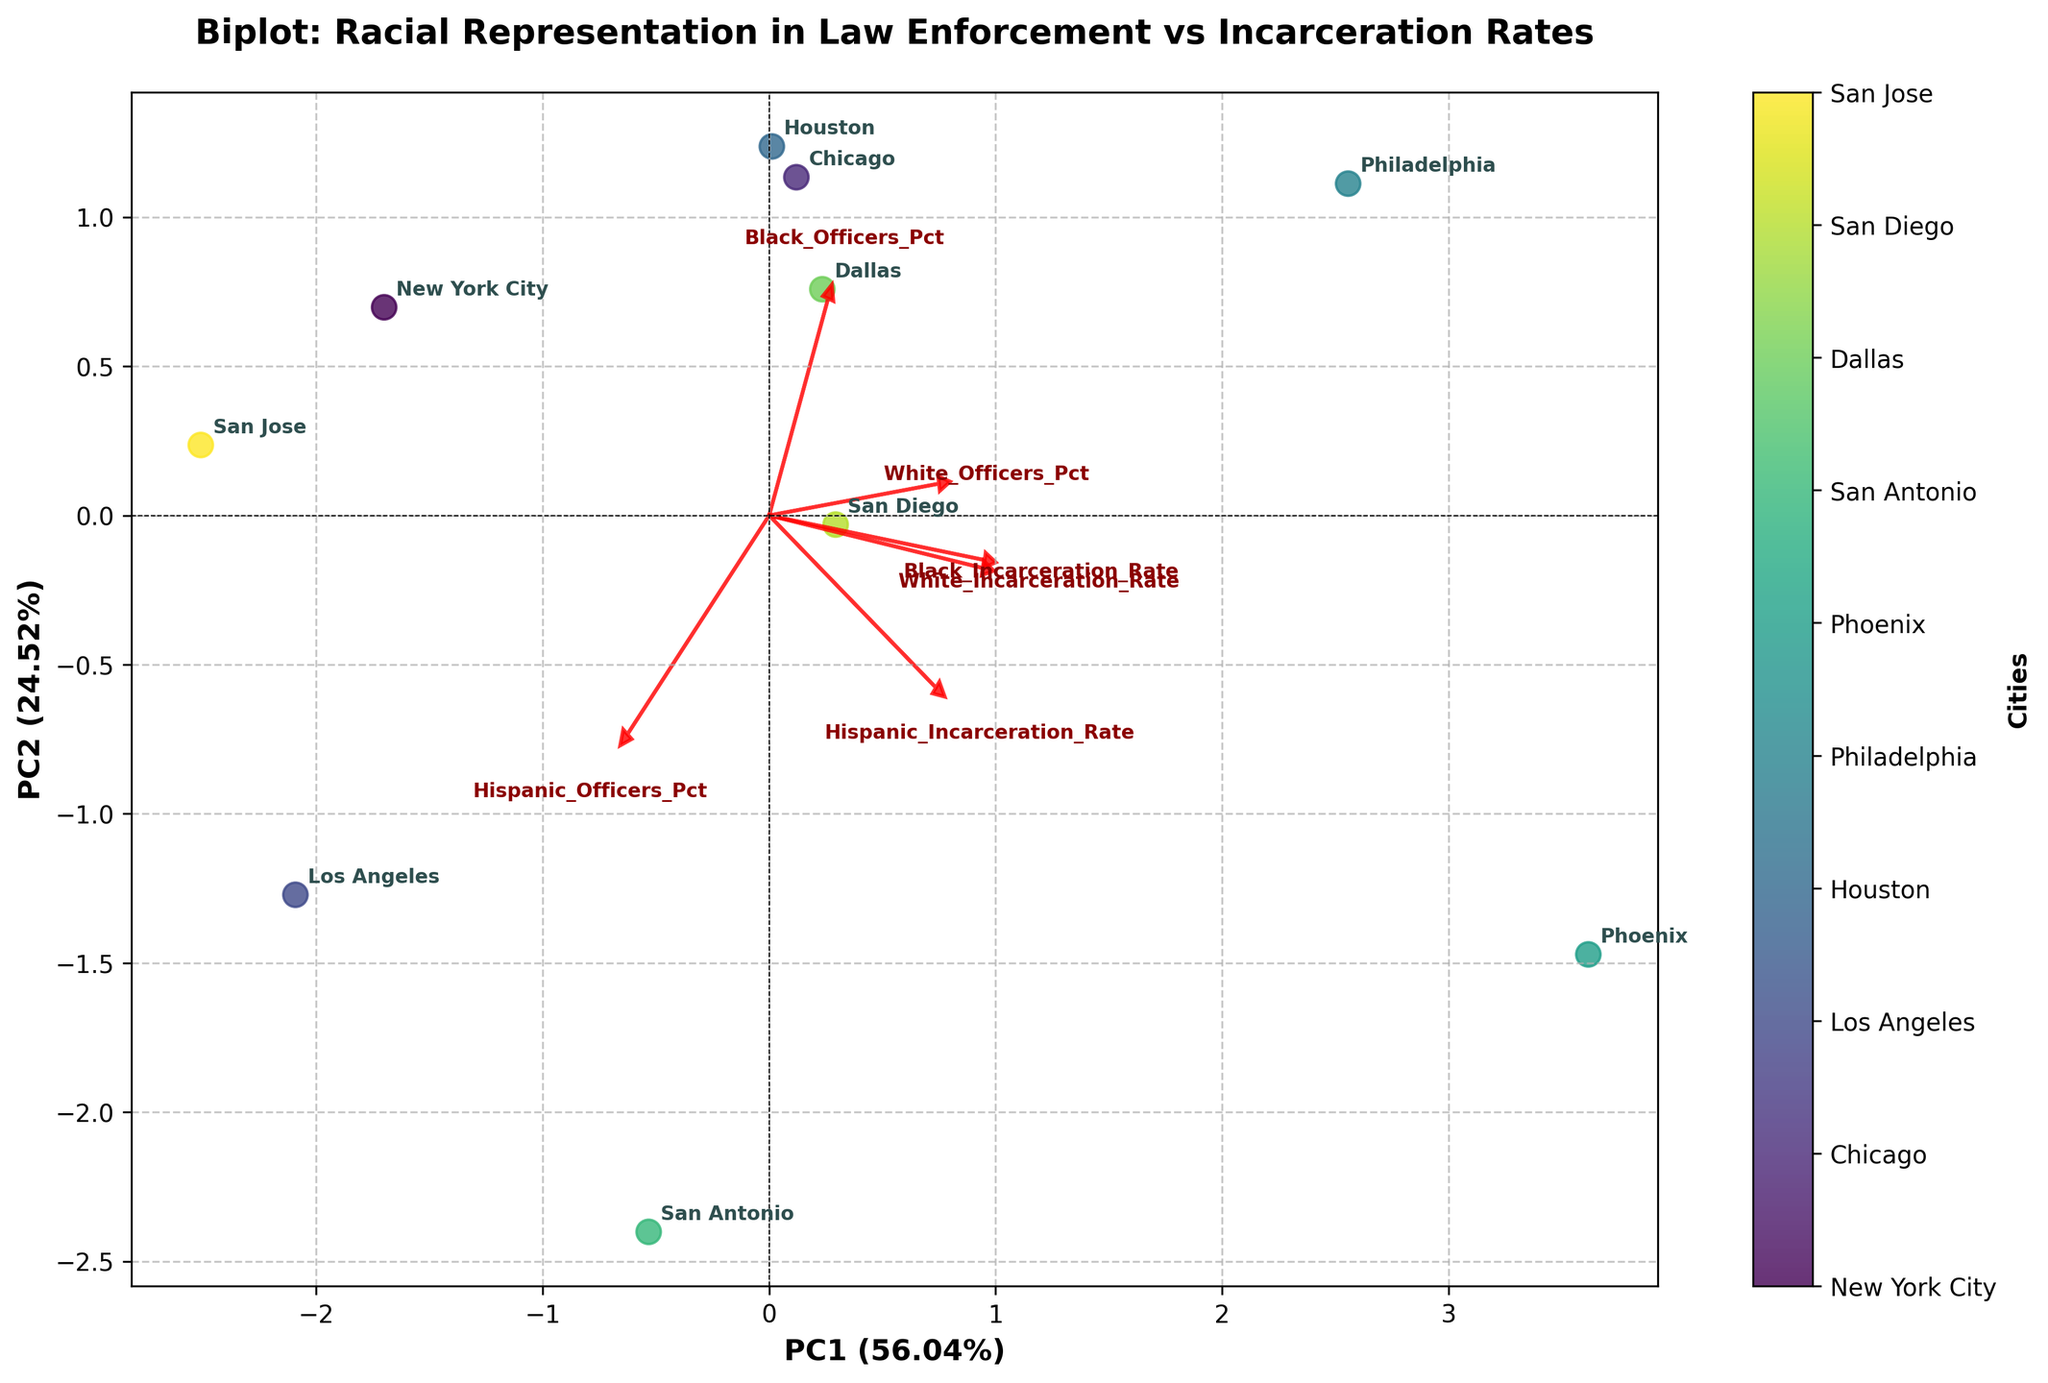What is the title of the biplot? The title is displayed at the top of the figure. It reads "Biplot: Racial Representation in Law Enforcement vs Incarceration Rates".
Answer: Biplot: Racial Representation in Law Enforcement vs Incarceration Rates How many cities are represented in the biplot? Count the number of unique labels (one for each city) annotated in the plot. There are labels for "New York City", "Chicago", "Los Angeles", "Houston", "Philadelphia", "Phoenix", "San Antonio", "Dallas", "San Diego", and "San Jose" – a total of 10 cities.
Answer: 10 Which feature is the most strongly associated with PC1? Observe the arrows representing feature vectors. The feature with the longest arrow length along PC1 is the one most associated with it. "White_Officers_Pct" has the longest projection on the first principal component axis.
Answer: White_Officers_Pct Which city is closely associated with a higher percentage of Hispanic officers and a higher Hispanic incarceration rate? Look for the city that lies in the direction where the arrows for "Hispanic_Officers_Pct" and "Hispanic_Incarceration_Rate" are pointing. The city in that direction is "San Antonio".
Answer: San Antonio What is the explained variance ratio for PC2? The explained variance ratio for PC2 is given on the y-axis label. It states "PC2 (19.37%)", so the explained variance is 19.37%.
Answer: 19.37% Which city has a low percentage of Black officers but a relatively high percentage of Hispanic officers? Identify the city positioned near the "Hispanic_Officers_Pct" axis but away from the "Black_Officers_Pct" axis. "San Jose" fits this description due to its low percentage of Black officers and higher percentage of Hispanic officers.
Answer: San Jose Compare the positions of New York City and Phoenix. Which one has a higher PC1 score? Observe the PC1 axis (horizontal axis) and compare the positions of "New York City" and "Phoenix". "Phoenix" is located further along the positive PC1 axis compared to "New York City".
Answer: Phoenix Which feature has little to no association with PC2? The feature vector that is closest to the horizontal (PC1) axis indicates a minimal association with PC2. "White_Incarceration_Rate" has the shortest projection in the PC2 direction.
Answer: White_Incarceration_Rate How are Black incarceration rate and Black officers percentage related according to the biplot? Analyze the direction and proximity of the arrows for "Black_Incarceration_Rate" and "Black_Officers_Pct". These arrows point in relatively similar directions, indicating a positive association.
Answer: Positively associated Which city seems to have a balance in the racial representation of law enforcement officers? Look for the city closest to the origin (0,0), indicating balanced representation. "New York City" is closest to the center, suggesting a balanced racial representation.
Answer: New York City 